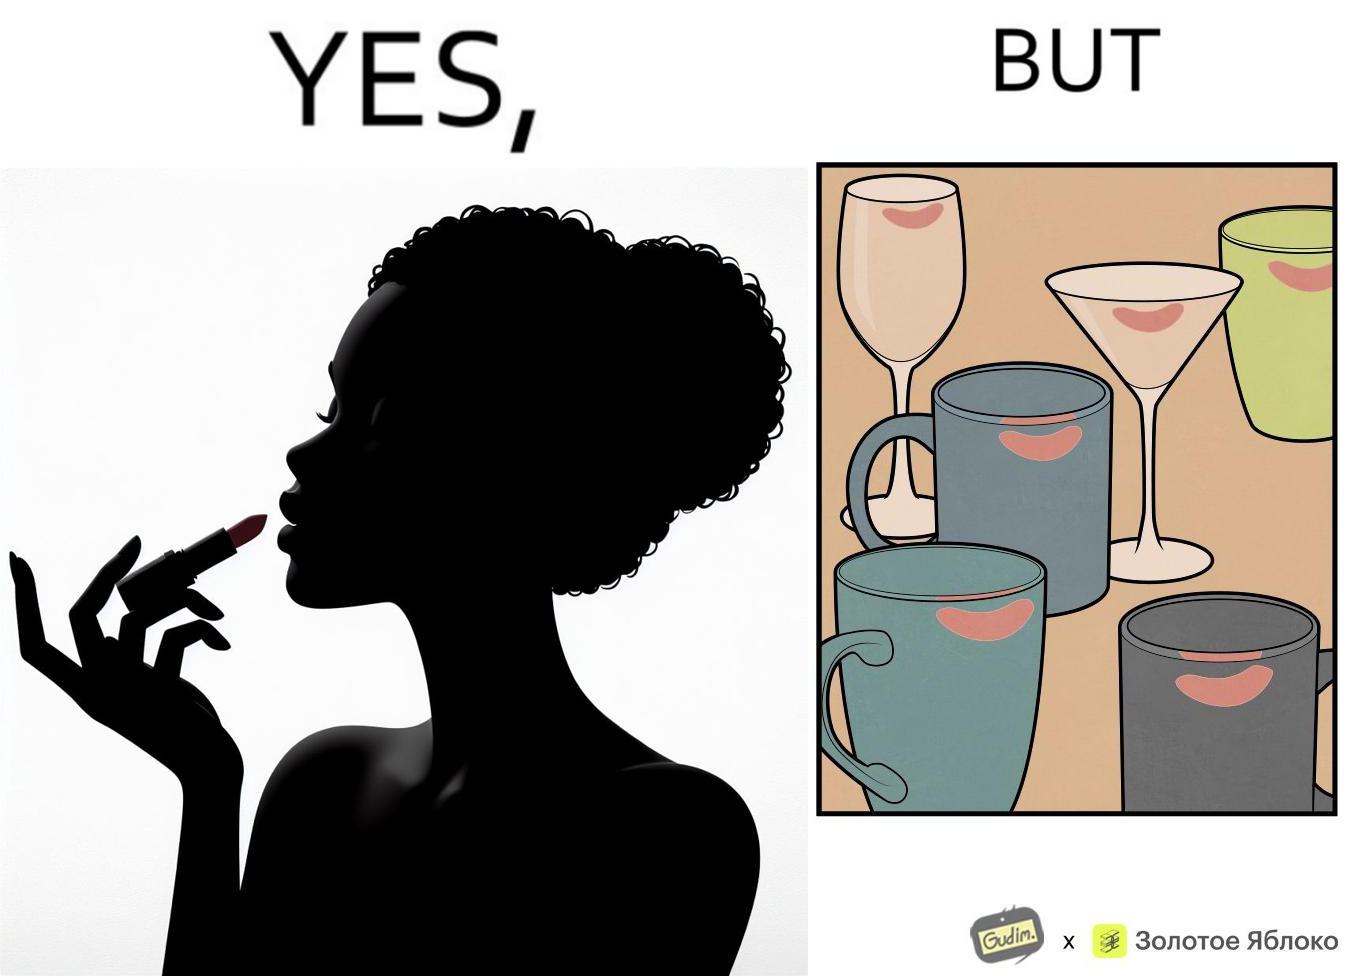What is shown in this image? The image is ironic, because the left image suggest that a person applies lipsticks on their lips to make their lips look attractive or to keep them hydrated but on the contrary it gets sticked to the glasses or mugs and gets wasted 